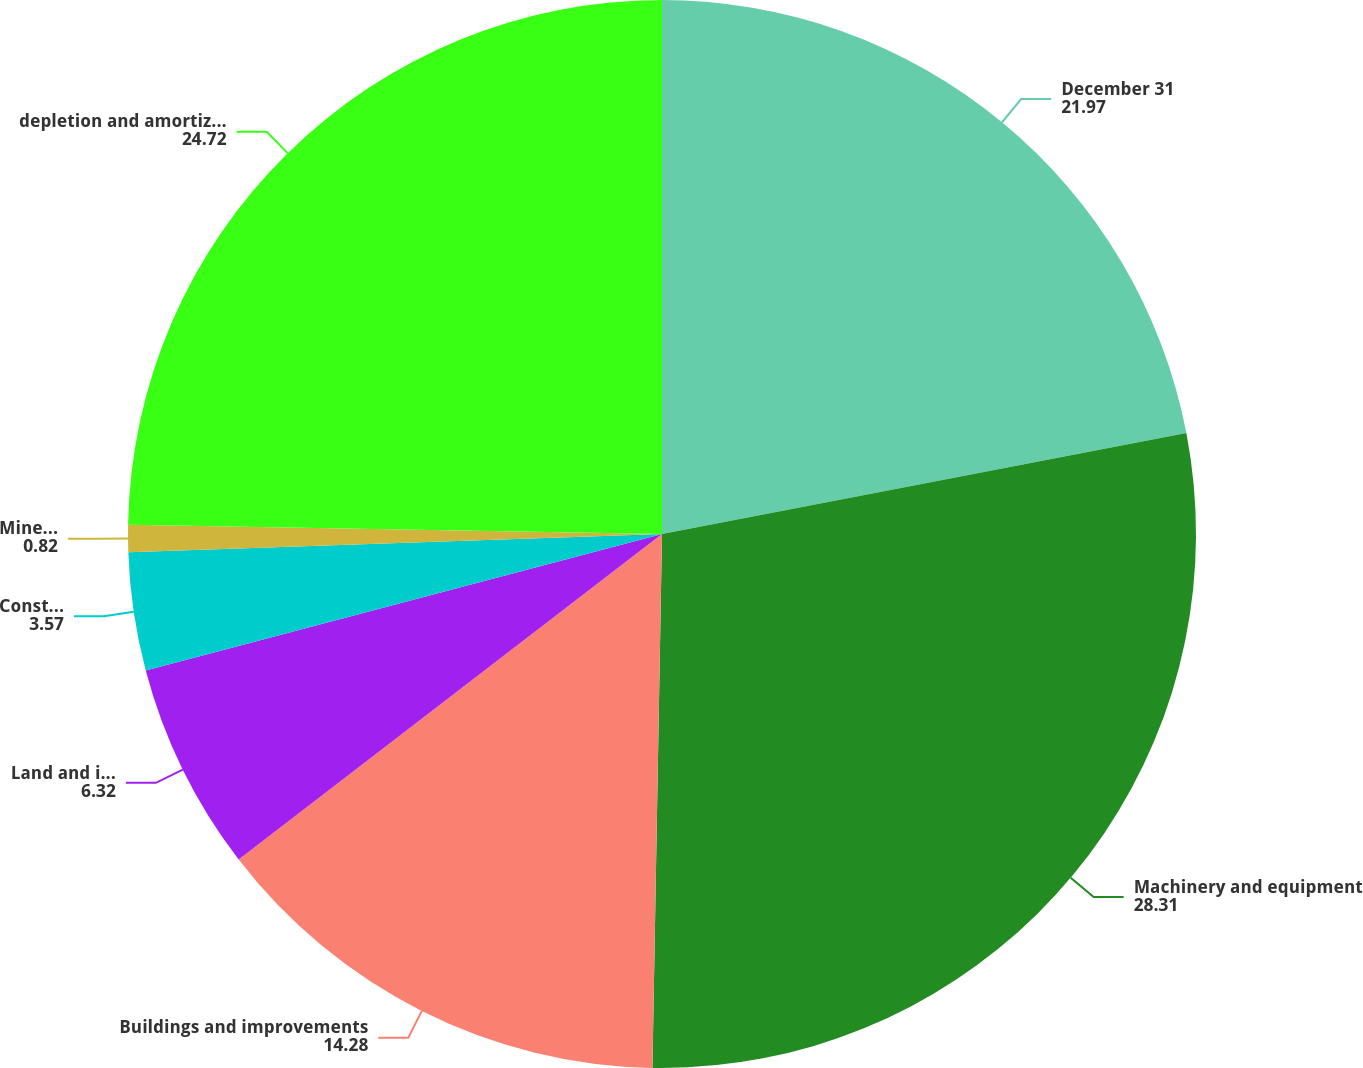Convert chart. <chart><loc_0><loc_0><loc_500><loc_500><pie_chart><fcel>December 31<fcel>Machinery and equipment<fcel>Buildings and improvements<fcel>Land and improvements<fcel>Construction in process<fcel>Mineral reserves<fcel>depletion and amortization<nl><fcel>21.97%<fcel>28.31%<fcel>14.28%<fcel>6.32%<fcel>3.57%<fcel>0.82%<fcel>24.72%<nl></chart> 